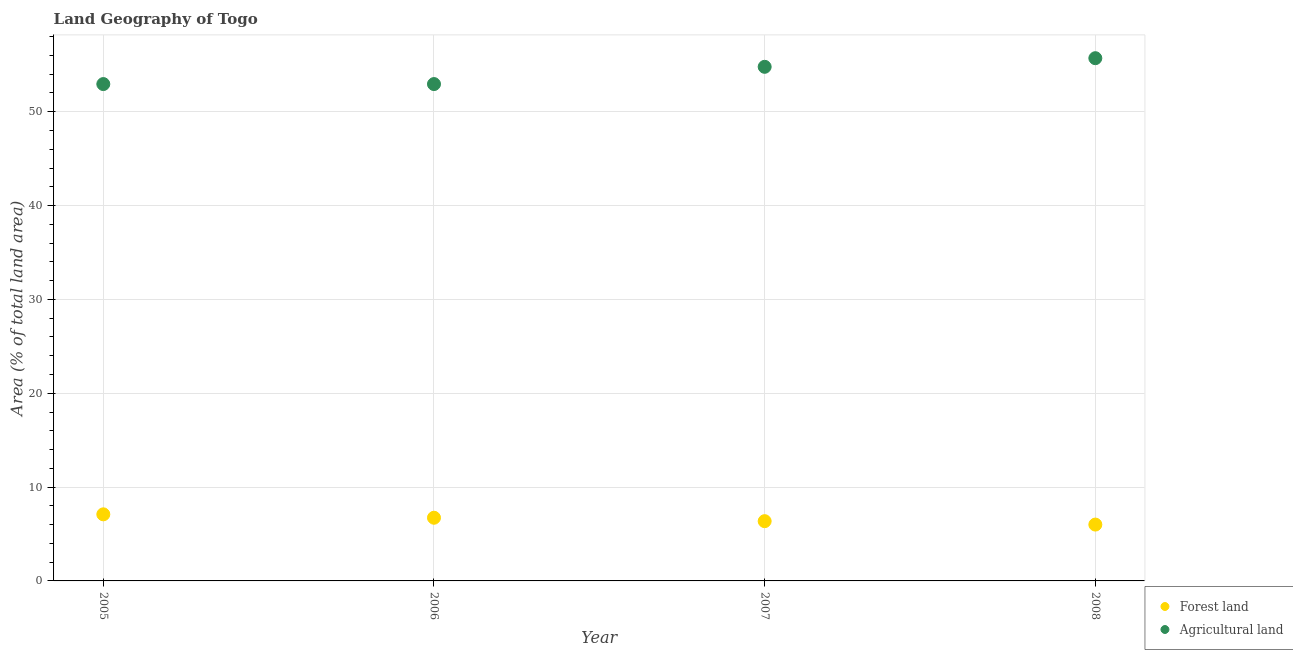Is the number of dotlines equal to the number of legend labels?
Give a very brief answer. Yes. What is the percentage of land area under forests in 2005?
Provide a succinct answer. 7.1. Across all years, what is the maximum percentage of land area under forests?
Your answer should be compact. 7.1. Across all years, what is the minimum percentage of land area under agriculture?
Provide a succinct answer. 52.95. What is the total percentage of land area under forests in the graph?
Keep it short and to the point. 26.2. What is the difference between the percentage of land area under agriculture in 2006 and that in 2008?
Offer a very short reply. -2.76. What is the difference between the percentage of land area under forests in 2006 and the percentage of land area under agriculture in 2005?
Your answer should be very brief. -46.22. What is the average percentage of land area under forests per year?
Make the answer very short. 6.55. In the year 2006, what is the difference between the percentage of land area under agriculture and percentage of land area under forests?
Offer a very short reply. 46.22. What is the ratio of the percentage of land area under agriculture in 2006 to that in 2008?
Ensure brevity in your answer.  0.95. Is the difference between the percentage of land area under forests in 2006 and 2008 greater than the difference between the percentage of land area under agriculture in 2006 and 2008?
Provide a short and direct response. Yes. What is the difference between the highest and the second highest percentage of land area under forests?
Keep it short and to the point. 0.36. What is the difference between the highest and the lowest percentage of land area under forests?
Give a very brief answer. 1.09. How many years are there in the graph?
Give a very brief answer. 4. Does the graph contain any zero values?
Provide a succinct answer. No. Does the graph contain grids?
Make the answer very short. Yes. Where does the legend appear in the graph?
Your response must be concise. Bottom right. How are the legend labels stacked?
Provide a short and direct response. Vertical. What is the title of the graph?
Your answer should be very brief. Land Geography of Togo. What is the label or title of the Y-axis?
Give a very brief answer. Area (% of total land area). What is the Area (% of total land area) in Forest land in 2005?
Offer a terse response. 7.1. What is the Area (% of total land area) in Agricultural land in 2005?
Your answer should be very brief. 52.95. What is the Area (% of total land area) in Forest land in 2006?
Give a very brief answer. 6.73. What is the Area (% of total land area) in Agricultural land in 2006?
Your answer should be very brief. 52.95. What is the Area (% of total land area) of Forest land in 2007?
Your response must be concise. 6.37. What is the Area (% of total land area) of Agricultural land in 2007?
Your response must be concise. 54.79. What is the Area (% of total land area) in Forest land in 2008?
Offer a terse response. 6. What is the Area (% of total land area) of Agricultural land in 2008?
Your response must be concise. 55.71. Across all years, what is the maximum Area (% of total land area) of Forest land?
Provide a short and direct response. 7.1. Across all years, what is the maximum Area (% of total land area) of Agricultural land?
Keep it short and to the point. 55.71. Across all years, what is the minimum Area (% of total land area) in Forest land?
Offer a very short reply. 6. Across all years, what is the minimum Area (% of total land area) in Agricultural land?
Provide a succinct answer. 52.95. What is the total Area (% of total land area) in Forest land in the graph?
Your answer should be compact. 26.2. What is the total Area (% of total land area) in Agricultural land in the graph?
Your answer should be very brief. 216.4. What is the difference between the Area (% of total land area) of Forest land in 2005 and that in 2006?
Provide a short and direct response. 0.36. What is the difference between the Area (% of total land area) of Agricultural land in 2005 and that in 2006?
Give a very brief answer. 0. What is the difference between the Area (% of total land area) of Forest land in 2005 and that in 2007?
Keep it short and to the point. 0.73. What is the difference between the Area (% of total land area) of Agricultural land in 2005 and that in 2007?
Keep it short and to the point. -1.84. What is the difference between the Area (% of total land area) of Forest land in 2005 and that in 2008?
Ensure brevity in your answer.  1.09. What is the difference between the Area (% of total land area) in Agricultural land in 2005 and that in 2008?
Provide a succinct answer. -2.76. What is the difference between the Area (% of total land area) in Forest land in 2006 and that in 2007?
Keep it short and to the point. 0.36. What is the difference between the Area (% of total land area) in Agricultural land in 2006 and that in 2007?
Provide a succinct answer. -1.84. What is the difference between the Area (% of total land area) of Forest land in 2006 and that in 2008?
Offer a terse response. 0.73. What is the difference between the Area (% of total land area) of Agricultural land in 2006 and that in 2008?
Ensure brevity in your answer.  -2.76. What is the difference between the Area (% of total land area) in Forest land in 2007 and that in 2008?
Give a very brief answer. 0.36. What is the difference between the Area (% of total land area) in Agricultural land in 2007 and that in 2008?
Your answer should be compact. -0.92. What is the difference between the Area (% of total land area) in Forest land in 2005 and the Area (% of total land area) in Agricultural land in 2006?
Your answer should be compact. -45.85. What is the difference between the Area (% of total land area) of Forest land in 2005 and the Area (% of total land area) of Agricultural land in 2007?
Your answer should be compact. -47.69. What is the difference between the Area (% of total land area) in Forest land in 2005 and the Area (% of total land area) in Agricultural land in 2008?
Keep it short and to the point. -48.61. What is the difference between the Area (% of total land area) of Forest land in 2006 and the Area (% of total land area) of Agricultural land in 2007?
Your response must be concise. -48.06. What is the difference between the Area (% of total land area) in Forest land in 2006 and the Area (% of total land area) in Agricultural land in 2008?
Your answer should be very brief. -48.98. What is the difference between the Area (% of total land area) of Forest land in 2007 and the Area (% of total land area) of Agricultural land in 2008?
Offer a terse response. -49.34. What is the average Area (% of total land area) in Forest land per year?
Give a very brief answer. 6.55. What is the average Area (% of total land area) of Agricultural land per year?
Offer a terse response. 54.1. In the year 2005, what is the difference between the Area (% of total land area) in Forest land and Area (% of total land area) in Agricultural land?
Your answer should be very brief. -45.85. In the year 2006, what is the difference between the Area (% of total land area) in Forest land and Area (% of total land area) in Agricultural land?
Provide a succinct answer. -46.22. In the year 2007, what is the difference between the Area (% of total land area) in Forest land and Area (% of total land area) in Agricultural land?
Give a very brief answer. -48.42. In the year 2008, what is the difference between the Area (% of total land area) of Forest land and Area (% of total land area) of Agricultural land?
Ensure brevity in your answer.  -49.7. What is the ratio of the Area (% of total land area) of Forest land in 2005 to that in 2006?
Keep it short and to the point. 1.05. What is the ratio of the Area (% of total land area) of Agricultural land in 2005 to that in 2006?
Offer a very short reply. 1. What is the ratio of the Area (% of total land area) of Forest land in 2005 to that in 2007?
Make the answer very short. 1.11. What is the ratio of the Area (% of total land area) in Agricultural land in 2005 to that in 2007?
Provide a succinct answer. 0.97. What is the ratio of the Area (% of total land area) of Forest land in 2005 to that in 2008?
Make the answer very short. 1.18. What is the ratio of the Area (% of total land area) of Agricultural land in 2005 to that in 2008?
Your response must be concise. 0.95. What is the ratio of the Area (% of total land area) of Forest land in 2006 to that in 2007?
Keep it short and to the point. 1.06. What is the ratio of the Area (% of total land area) in Agricultural land in 2006 to that in 2007?
Offer a very short reply. 0.97. What is the ratio of the Area (% of total land area) of Forest land in 2006 to that in 2008?
Keep it short and to the point. 1.12. What is the ratio of the Area (% of total land area) in Agricultural land in 2006 to that in 2008?
Keep it short and to the point. 0.95. What is the ratio of the Area (% of total land area) in Forest land in 2007 to that in 2008?
Provide a succinct answer. 1.06. What is the ratio of the Area (% of total land area) in Agricultural land in 2007 to that in 2008?
Keep it short and to the point. 0.98. What is the difference between the highest and the second highest Area (% of total land area) in Forest land?
Offer a terse response. 0.36. What is the difference between the highest and the second highest Area (% of total land area) of Agricultural land?
Keep it short and to the point. 0.92. What is the difference between the highest and the lowest Area (% of total land area) of Forest land?
Give a very brief answer. 1.09. What is the difference between the highest and the lowest Area (% of total land area) of Agricultural land?
Make the answer very short. 2.76. 